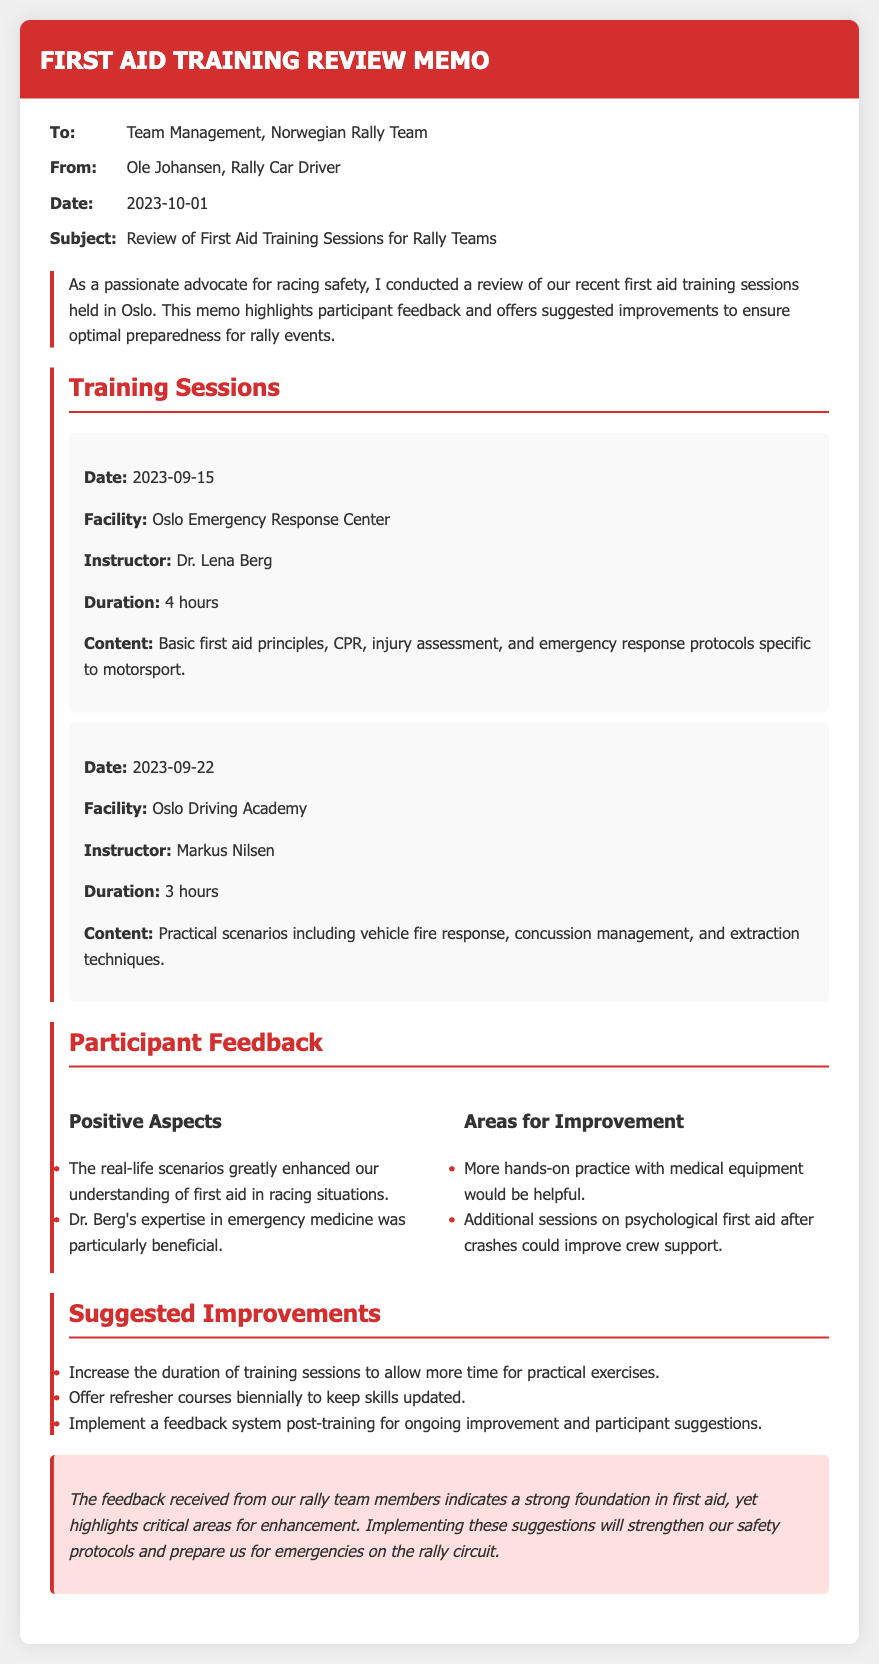what is the date of the memo? The date of the memo is stated in the document as "2023-10-01."
Answer: 2023-10-01 who conducted the review of the first aid training sessions? The review of the first aid training sessions was conducted by Ole Johansen, as mentioned in the document.
Answer: Ole Johansen how long was the training session on 2023-09-15? The duration of the training session on 2023-09-15 is specified as 4 hours.
Answer: 4 hours what is one positive aspect of the training according to participant feedback? The document lists positive aspects, one being that "the real-life scenarios greatly enhanced our understanding of first aid in racing situations."
Answer: real-life scenarios what improvement is suggested regarding the training session duration? The memo suggests that the duration of training sessions should be increased to allow more time for practical exercises.
Answer: increase duration what type of courses does the memo recommend offering biennially? The memo recommends offering refresher courses biennially to keep skills updated, highlighting an ongoing training need.
Answer: refresher courses who was the instructor for the training session on 2023-09-22? The instructor for the training session on 2023-09-22 is mentioned as Markus Nilsen.
Answer: Markus Nilsen what facility was used for the training session on 2023-09-22? The facility for the training session on this date is identified as the Oslo Driving Academy.
Answer: Oslo Driving Academy what does the conclusion emphasize about the received feedback? The conclusion emphasizes that the feedback indicates a strong foundation in first aid but highlights critical areas for enhancement.
Answer: strong foundation 